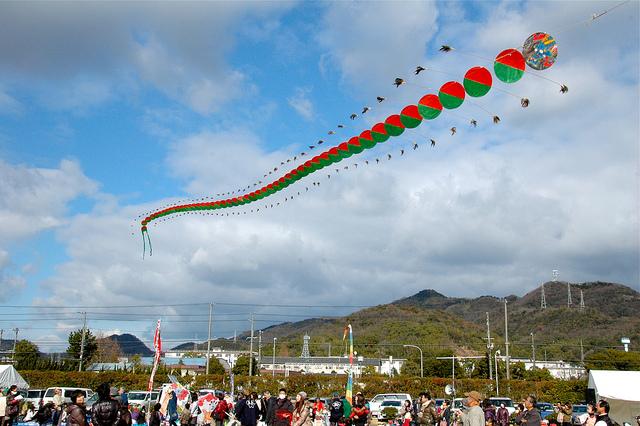Is the sky cloudy?
Answer briefly. Yes. What is in the sky?
Write a very short answer. Kite. Are the mountains in the background?
Write a very short answer. Yes. How many kites are there?
Write a very short answer. 1. 